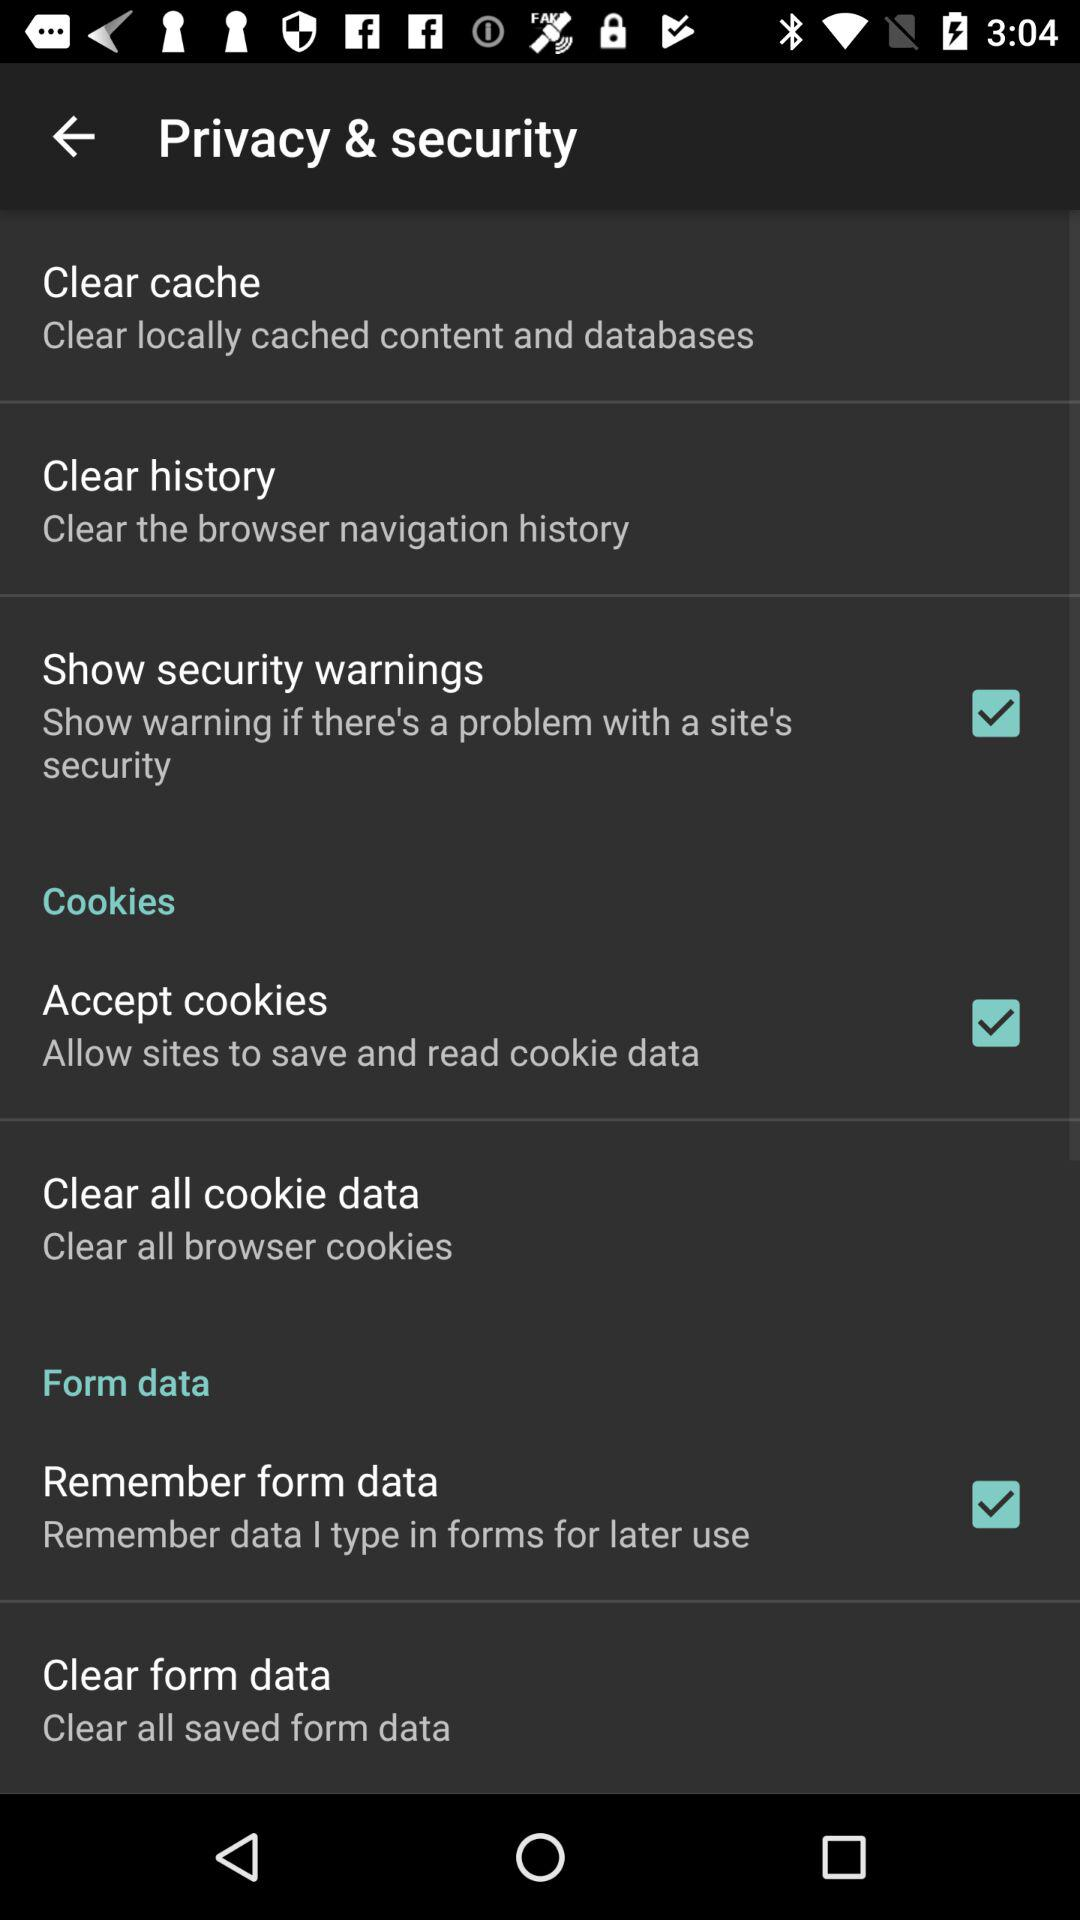What is the status of "Clear cache"?
When the provided information is insufficient, respond with <no answer>. <no answer> 